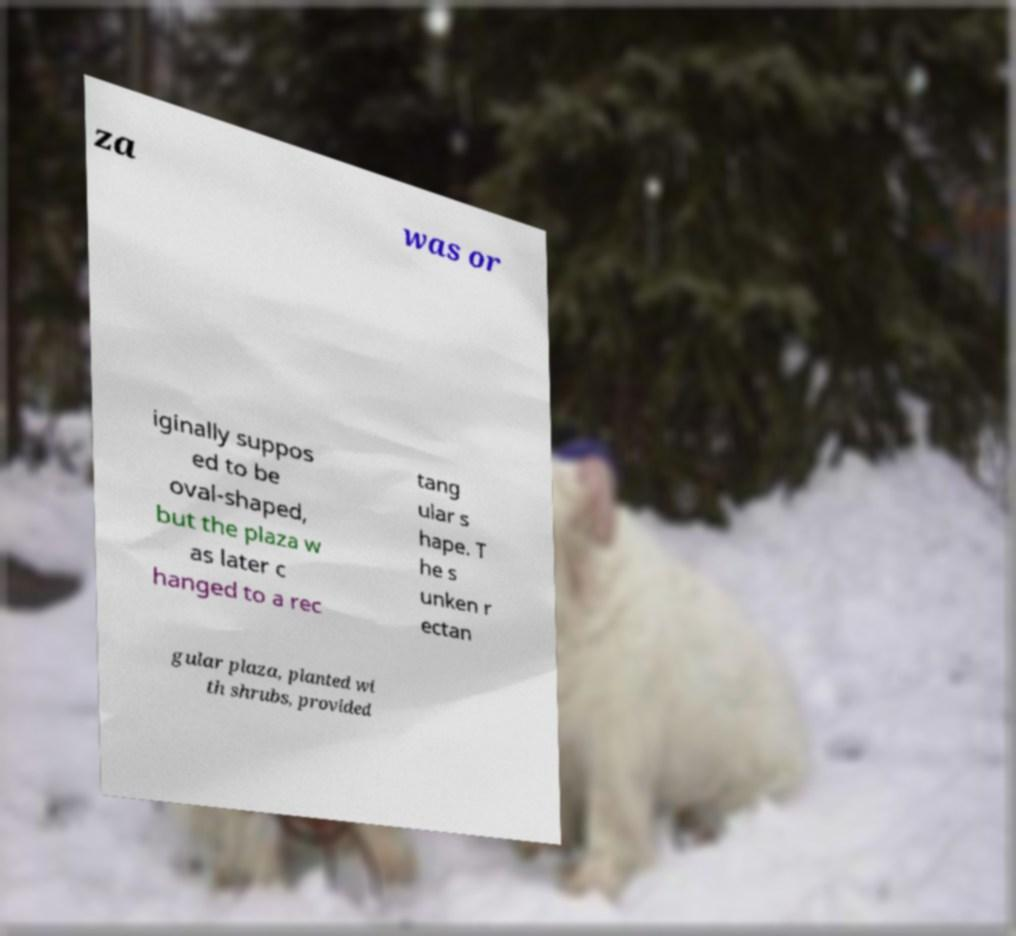Please identify and transcribe the text found in this image. za was or iginally suppos ed to be oval-shaped, but the plaza w as later c hanged to a rec tang ular s hape. T he s unken r ectan gular plaza, planted wi th shrubs, provided 